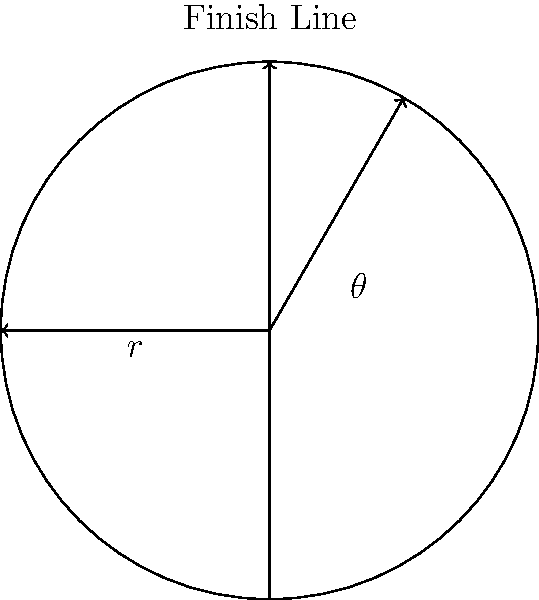In a motorcycle speedway race, a rider completes one lap around a circular track with a radius of 100 meters in exactly 12 seconds. What is the average speed of the motorcycle in kilometers per hour? To solve this problem, let's follow these steps:

1) First, we need to calculate the distance traveled in one lap. The formula for the circumference of a circle is:
   $$C = 2\pi r$$
   where $r$ is the radius.

2) Plugging in our value:
   $$C = 2\pi \cdot 100 = 200\pi \approx 628.32 \text{ meters}$$

3) Now we know the distance traveled (628.32 meters) and the time taken (12 seconds). We can calculate the speed using the formula:
   $$\text{Speed} = \frac{\text{Distance}}{\text{Time}}$$

4) Plugging in our values:
   $$\text{Speed} = \frac{628.32 \text{ meters}}{12 \text{ seconds}} = 52.36 \text{ m/s}$$

5) The question asks for the speed in km/h, so we need to convert:
   $$52.36 \frac{\text{m}}{\text{s}} \cdot \frac{3600 \text{ s}}{1 \text{ h}} \cdot \frac{1 \text{ km}}{1000 \text{ m}} = 188.496 \text{ km/h}$$

6) Rounding to the nearest whole number:
   $$188.496 \text{ km/h} \approx 188 \text{ km/h}$$
Answer: 188 km/h 